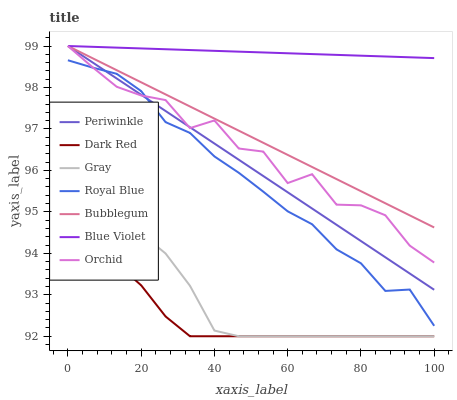Does Dark Red have the minimum area under the curve?
Answer yes or no. Yes. Does Blue Violet have the maximum area under the curve?
Answer yes or no. Yes. Does Bubblegum have the minimum area under the curve?
Answer yes or no. No. Does Bubblegum have the maximum area under the curve?
Answer yes or no. No. Is Bubblegum the smoothest?
Answer yes or no. Yes. Is Orchid the roughest?
Answer yes or no. Yes. Is Dark Red the smoothest?
Answer yes or no. No. Is Dark Red the roughest?
Answer yes or no. No. Does Bubblegum have the lowest value?
Answer yes or no. No. Does Dark Red have the highest value?
Answer yes or no. No. Is Dark Red less than Bubblegum?
Answer yes or no. Yes. Is Periwinkle greater than Dark Red?
Answer yes or no. Yes. Does Dark Red intersect Bubblegum?
Answer yes or no. No. 